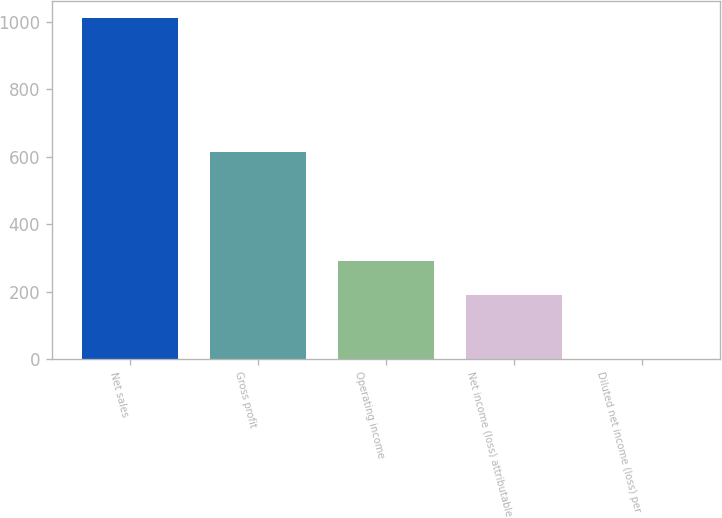<chart> <loc_0><loc_0><loc_500><loc_500><bar_chart><fcel>Net sales<fcel>Gross profit<fcel>Operating income<fcel>Net income (loss) attributable<fcel>Diluted net income (loss) per<nl><fcel>1012.1<fcel>614.1<fcel>290.33<fcel>189.2<fcel>0.77<nl></chart> 